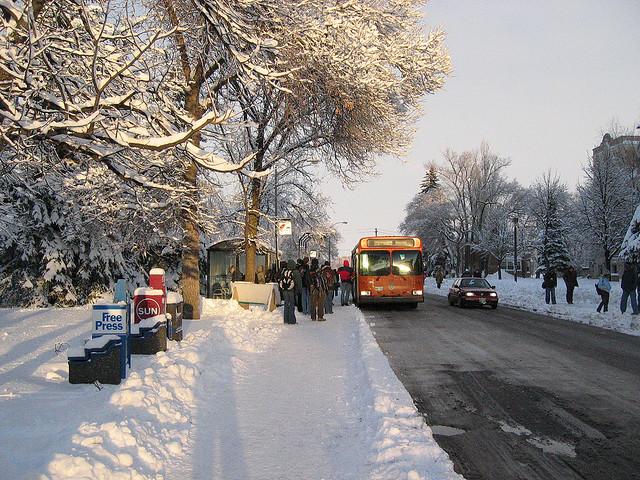Is the snow deep?
Keep it brief. Yes. What part is clear?
Quick response, please. Road. How many care do you see?
Write a very short answer. 1. 